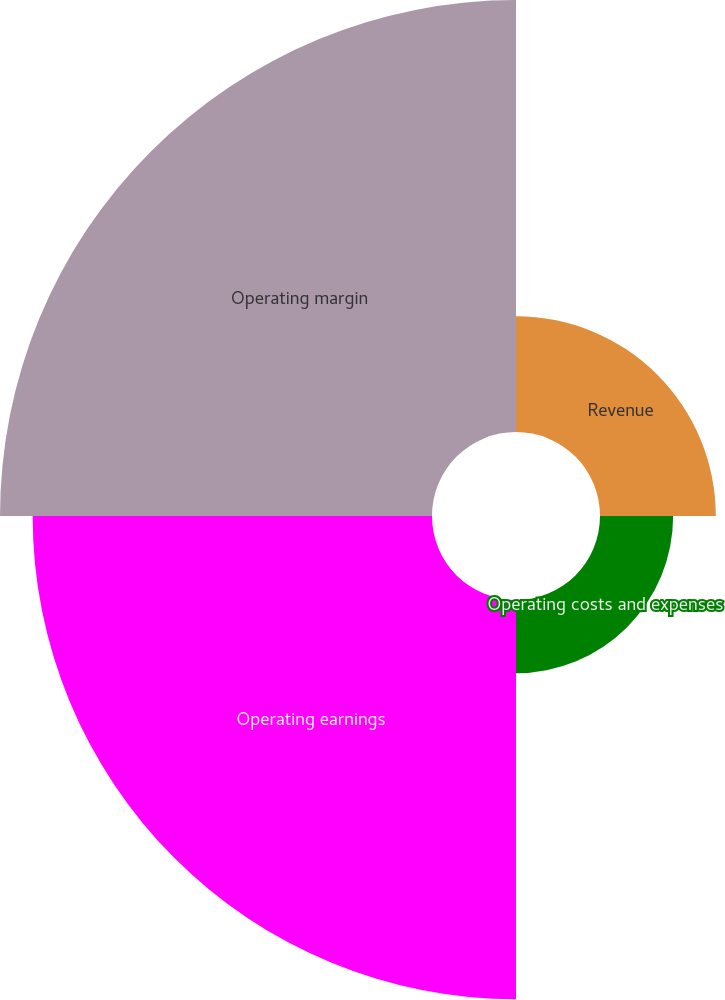Convert chart. <chart><loc_0><loc_0><loc_500><loc_500><pie_chart><fcel>Revenue<fcel>Operating costs and expenses<fcel>Operating earnings<fcel>Operating margin<nl><fcel>11.35%<fcel>7.17%<fcel>39.14%<fcel>42.34%<nl></chart> 